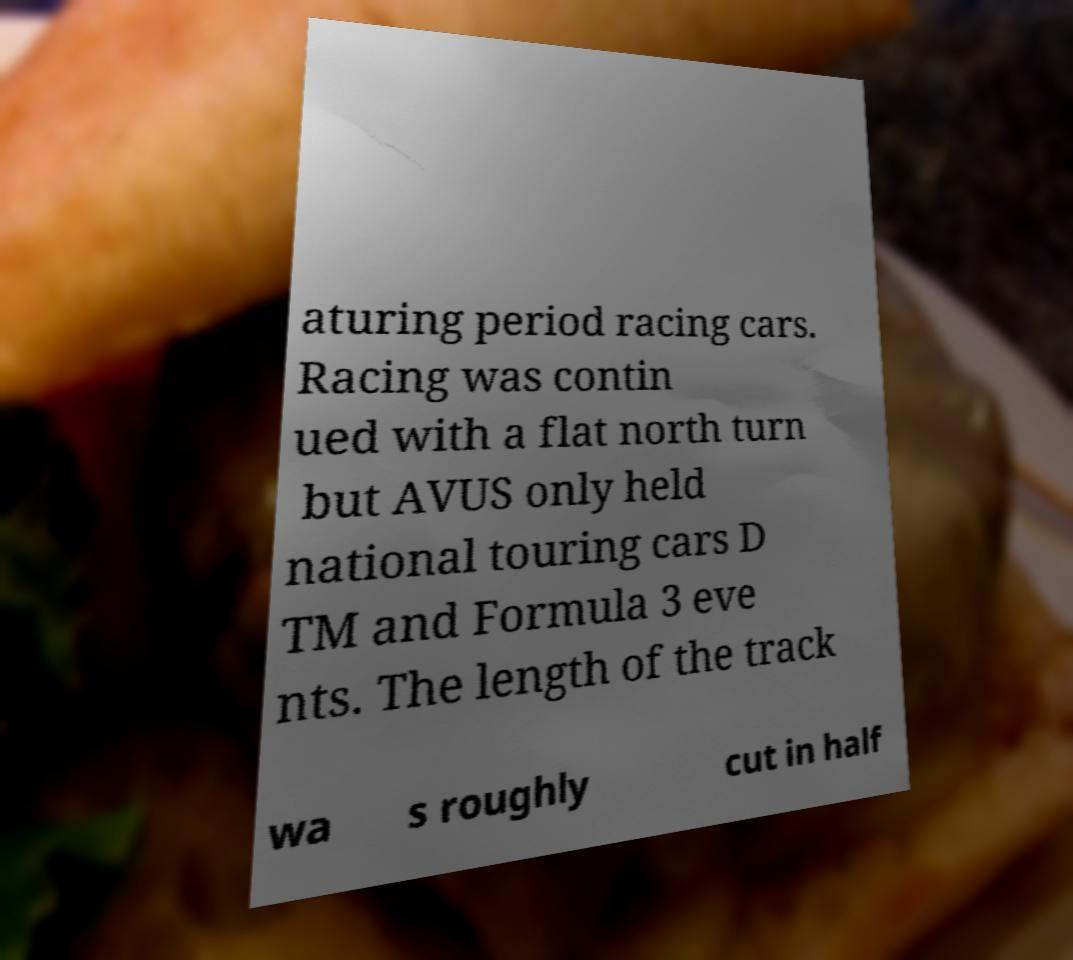Please identify and transcribe the text found in this image. aturing period racing cars. Racing was contin ued with a flat north turn but AVUS only held national touring cars D TM and Formula 3 eve nts. The length of the track wa s roughly cut in half 